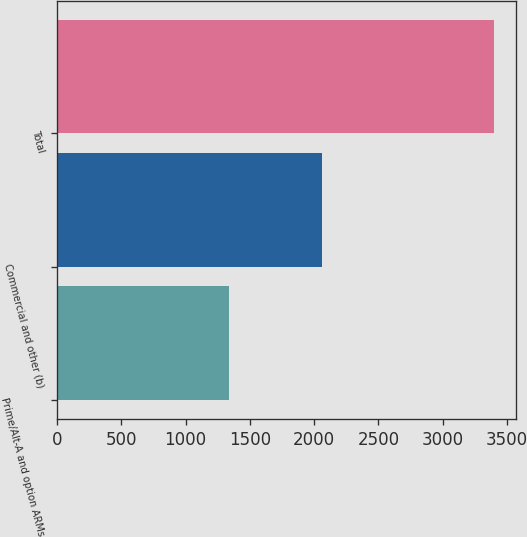Convert chart. <chart><loc_0><loc_0><loc_500><loc_500><bar_chart><fcel>Prime/Alt-A and option ARMs<fcel>Commercial and other (b)<fcel>Total<nl><fcel>1334<fcel>2064<fcel>3398<nl></chart> 